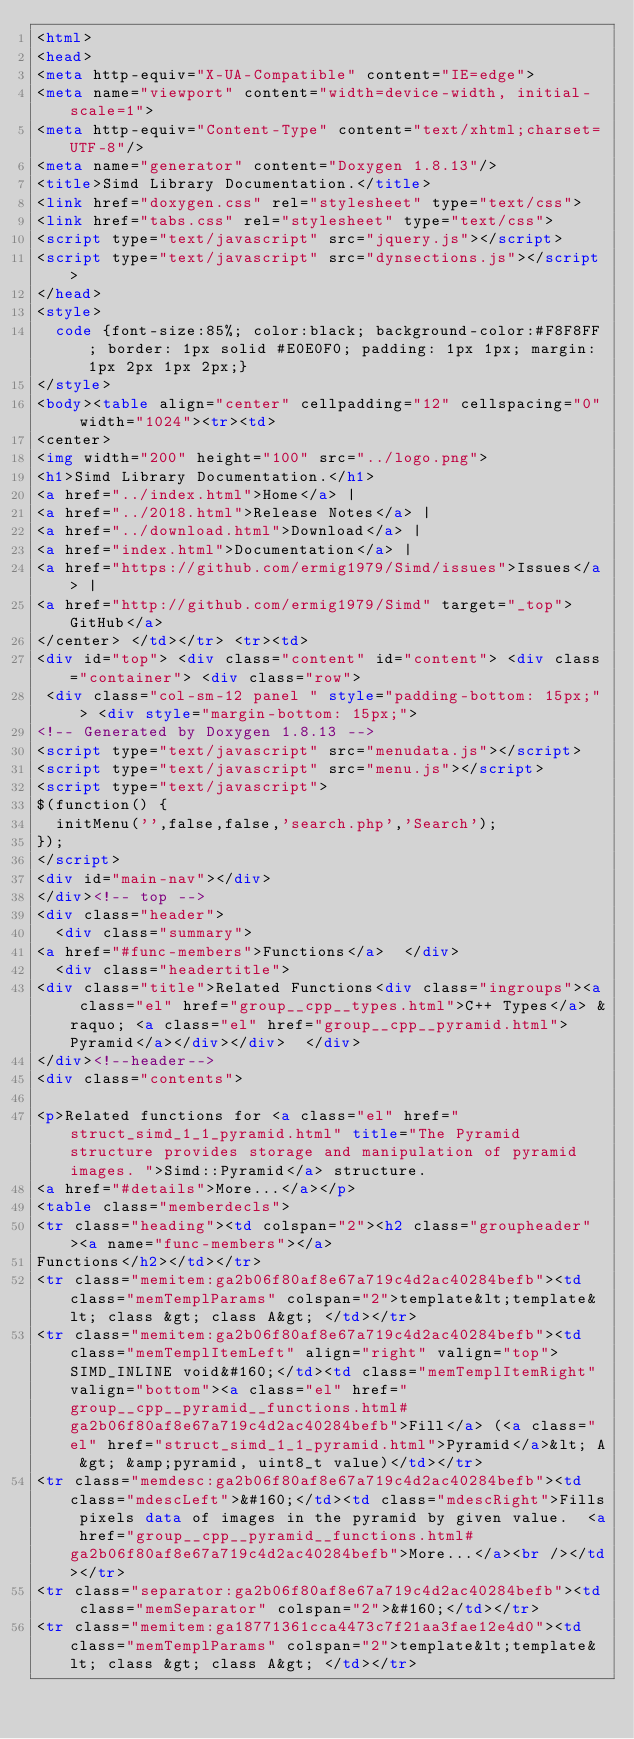Convert code to text. <code><loc_0><loc_0><loc_500><loc_500><_HTML_><html>
<head>
<meta http-equiv="X-UA-Compatible" content="IE=edge">
<meta name="viewport" content="width=device-width, initial-scale=1">
<meta http-equiv="Content-Type" content="text/xhtml;charset=UTF-8"/>
<meta name="generator" content="Doxygen 1.8.13"/>
<title>Simd Library Documentation.</title>
<link href="doxygen.css" rel="stylesheet" type="text/css">
<link href="tabs.css" rel="stylesheet" type="text/css">
<script type="text/javascript" src="jquery.js"></script>
<script type="text/javascript" src="dynsections.js"></script>
</head>
<style>
  code {font-size:85%; color:black; background-color:#F8F8FF; border: 1px solid #E0E0F0; padding: 1px 1px; margin: 1px 2px 1px 2px;}
</style>
<body><table align="center" cellpadding="12" cellspacing="0" width="1024"><tr><td>
<center>
<img width="200" height="100" src="../logo.png">
<h1>Simd Library Documentation.</h1>
<a href="../index.html">Home</a> |
<a href="../2018.html">Release Notes</a> | 
<a href="../download.html">Download</a> | 
<a href="index.html">Documentation</a> | 
<a href="https://github.com/ermig1979/Simd/issues">Issues</a> | 
<a href="http://github.com/ermig1979/Simd" target="_top">GitHub</a> 
</center> </td></tr> <tr><td>
<div id="top"> <div class="content" id="content"> <div class="container"> <div class="row"> 
 <div class="col-sm-12 panel " style="padding-bottom: 15px;"> <div style="margin-bottom: 15px;">
<!-- Generated by Doxygen 1.8.13 -->
<script type="text/javascript" src="menudata.js"></script>
<script type="text/javascript" src="menu.js"></script>
<script type="text/javascript">
$(function() {
  initMenu('',false,false,'search.php','Search');
});
</script>
<div id="main-nav"></div>
</div><!-- top -->
<div class="header">
  <div class="summary">
<a href="#func-members">Functions</a>  </div>
  <div class="headertitle">
<div class="title">Related Functions<div class="ingroups"><a class="el" href="group__cpp__types.html">C++ Types</a> &raquo; <a class="el" href="group__cpp__pyramid.html">Pyramid</a></div></div>  </div>
</div><!--header-->
<div class="contents">

<p>Related functions for <a class="el" href="struct_simd_1_1_pyramid.html" title="The Pyramid structure provides storage and manipulation of pyramid images. ">Simd::Pyramid</a> structure.  
<a href="#details">More...</a></p>
<table class="memberdecls">
<tr class="heading"><td colspan="2"><h2 class="groupheader"><a name="func-members"></a>
Functions</h2></td></tr>
<tr class="memitem:ga2b06f80af8e67a719c4d2ac40284befb"><td class="memTemplParams" colspan="2">template&lt;template&lt; class &gt; class A&gt; </td></tr>
<tr class="memitem:ga2b06f80af8e67a719c4d2ac40284befb"><td class="memTemplItemLeft" align="right" valign="top">SIMD_INLINE void&#160;</td><td class="memTemplItemRight" valign="bottom"><a class="el" href="group__cpp__pyramid__functions.html#ga2b06f80af8e67a719c4d2ac40284befb">Fill</a> (<a class="el" href="struct_simd_1_1_pyramid.html">Pyramid</a>&lt; A &gt; &amp;pyramid, uint8_t value)</td></tr>
<tr class="memdesc:ga2b06f80af8e67a719c4d2ac40284befb"><td class="mdescLeft">&#160;</td><td class="mdescRight">Fills pixels data of images in the pyramid by given value.  <a href="group__cpp__pyramid__functions.html#ga2b06f80af8e67a719c4d2ac40284befb">More...</a><br /></td></tr>
<tr class="separator:ga2b06f80af8e67a719c4d2ac40284befb"><td class="memSeparator" colspan="2">&#160;</td></tr>
<tr class="memitem:ga18771361cca4473c7f21aa3fae12e4d0"><td class="memTemplParams" colspan="2">template&lt;template&lt; class &gt; class A&gt; </td></tr></code> 